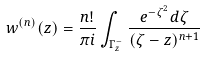Convert formula to latex. <formula><loc_0><loc_0><loc_500><loc_500>w ^ { ( n ) } ( z ) = \frac { n ! } { \pi i } \int _ { \Gamma _ { z } ^ { - } } \frac { e ^ { - \zeta ^ { 2 } } d \zeta } { ( \zeta - z ) ^ { n + 1 } }</formula> 